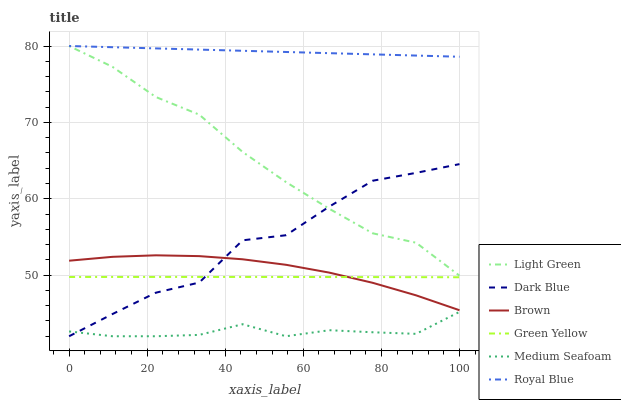Does Medium Seafoam have the minimum area under the curve?
Answer yes or no. Yes. Does Royal Blue have the maximum area under the curve?
Answer yes or no. Yes. Does Dark Blue have the minimum area under the curve?
Answer yes or no. No. Does Dark Blue have the maximum area under the curve?
Answer yes or no. No. Is Royal Blue the smoothest?
Answer yes or no. Yes. Is Dark Blue the roughest?
Answer yes or no. Yes. Is Dark Blue the smoothest?
Answer yes or no. No. Is Royal Blue the roughest?
Answer yes or no. No. Does Dark Blue have the lowest value?
Answer yes or no. Yes. Does Royal Blue have the lowest value?
Answer yes or no. No. Does Light Green have the highest value?
Answer yes or no. Yes. Does Dark Blue have the highest value?
Answer yes or no. No. Is Brown less than Light Green?
Answer yes or no. Yes. Is Brown greater than Medium Seafoam?
Answer yes or no. Yes. Does Dark Blue intersect Medium Seafoam?
Answer yes or no. Yes. Is Dark Blue less than Medium Seafoam?
Answer yes or no. No. Is Dark Blue greater than Medium Seafoam?
Answer yes or no. No. Does Brown intersect Light Green?
Answer yes or no. No. 